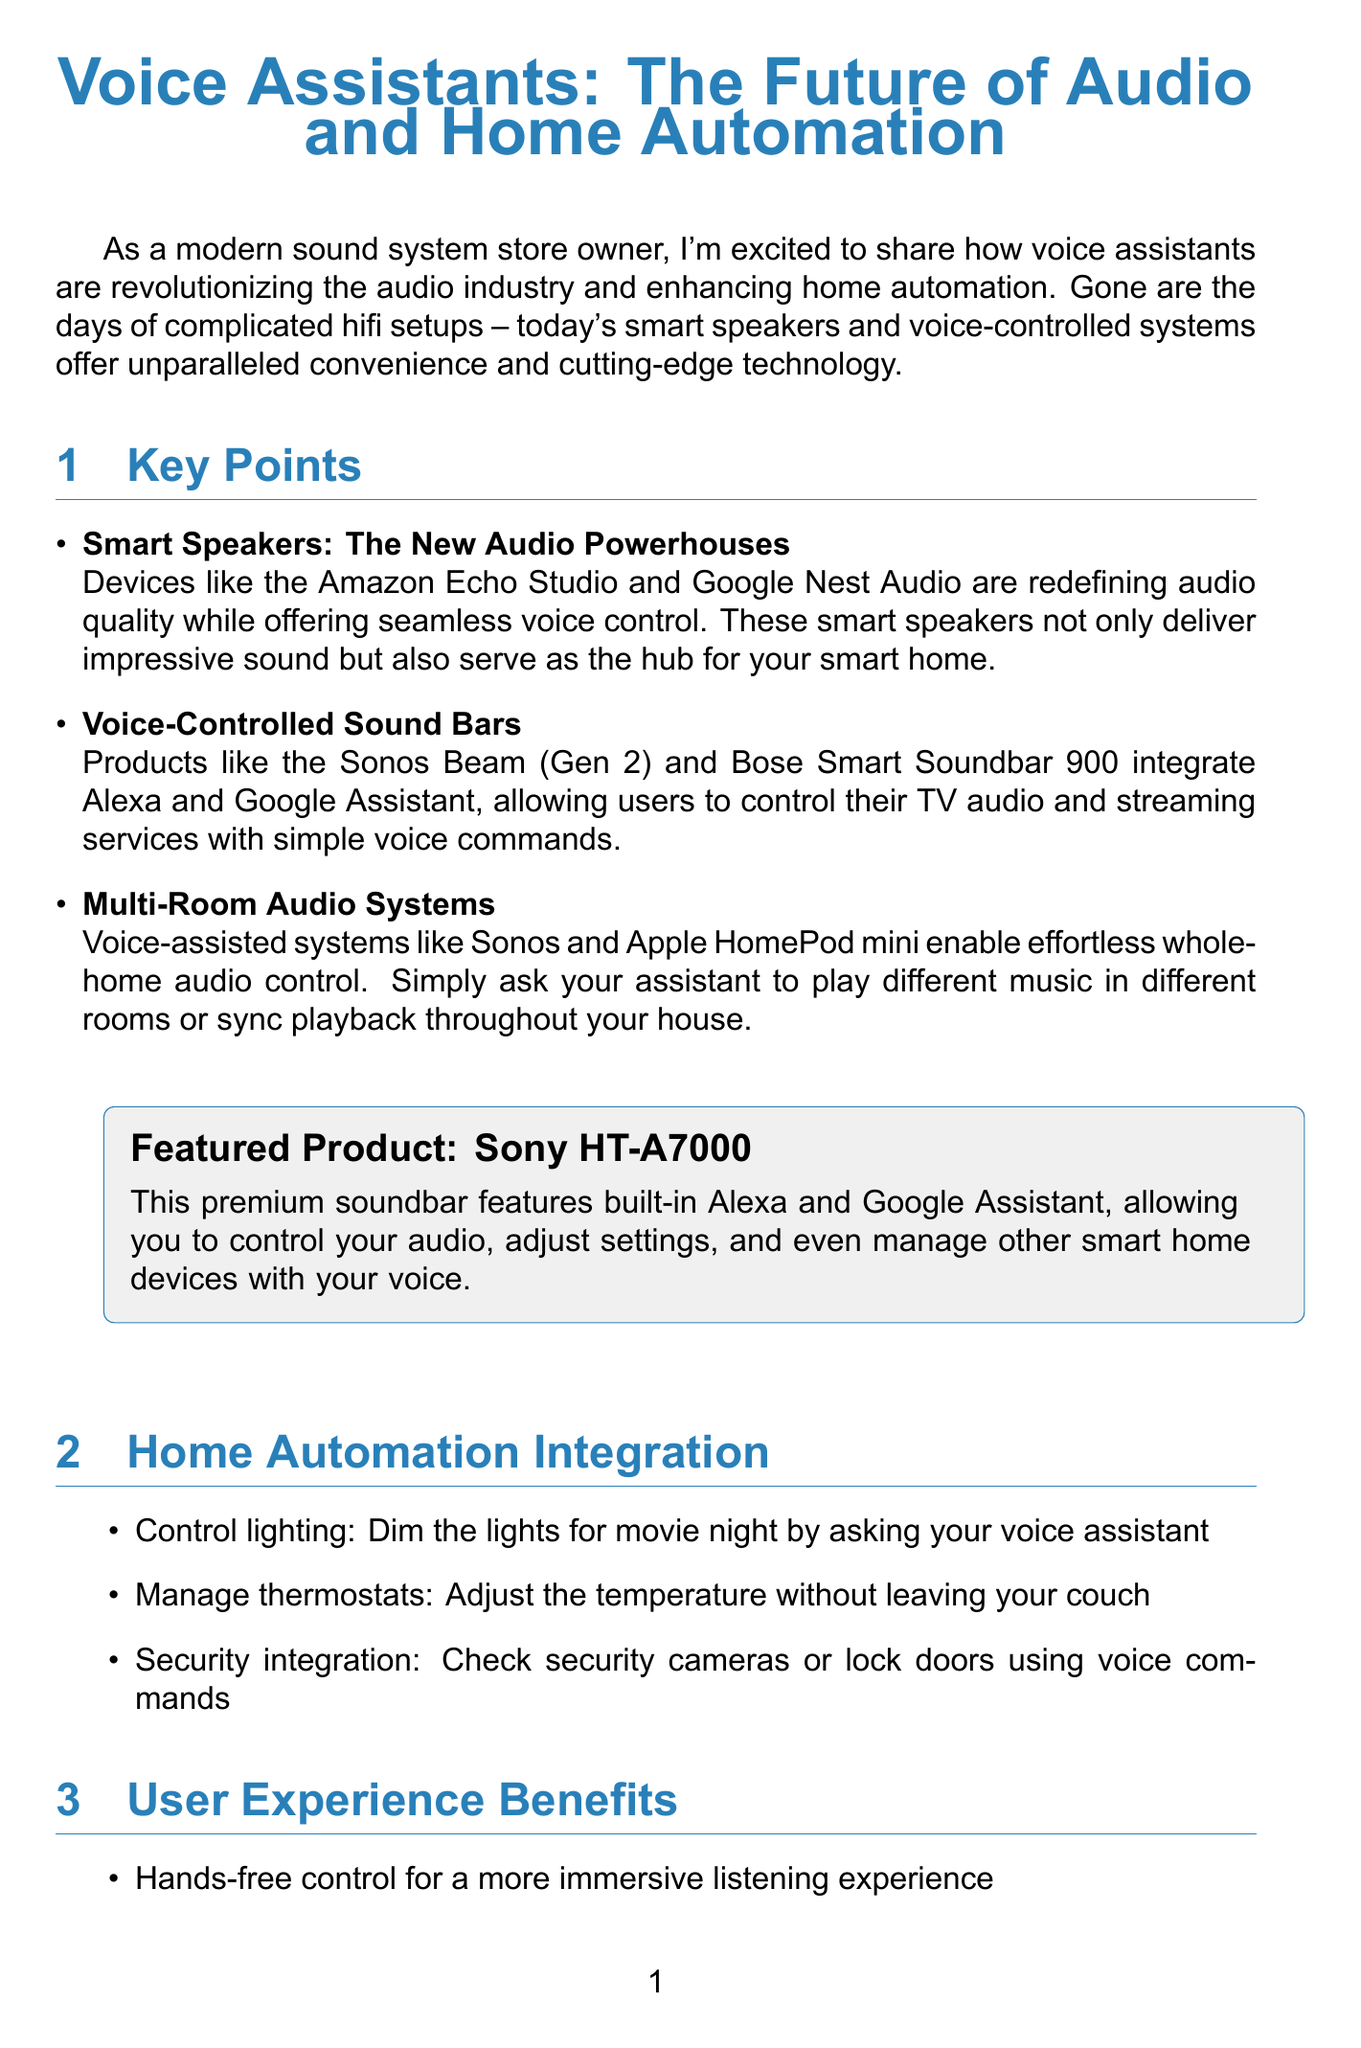What is the newsletter title? The title of the newsletter is explicitly stated at the beginning of the document.
Answer: Voice Assistants: The Future of Audio and Home Automation What product is featured in the newsletter? The featured product is highlighted in a special section within the document.
Answer: Sony HT-A7000 Which smart speaker is mentioned as an example? The document lists specific examples of smart speakers in the key points section.
Answer: Amazon Echo Studio What functionality do voice-controlled sound bars offer? This can be found in the paragraph describing what voice-controlled sound bars do.
Answer: Control TV audio and streaming services How many home automation features are listed? The home automation integration section contains a list of features; counting them gives the answer.
Answer: Three What is one benefit of user experience mentioned? One specific benefit is listed in the user experience section.
Answer: Hands-free control for a more immersive listening experience What future trend involves AI? The future trends section outlines upcoming innovations, and one involves artificial intelligence.
Answer: AI-powered sound optimization What type of systems do the Sonos and Apple HomePod mini represent? The context around them indicates what kind of audio systems they are categorized under.
Answer: Multi-Room Audio Systems 